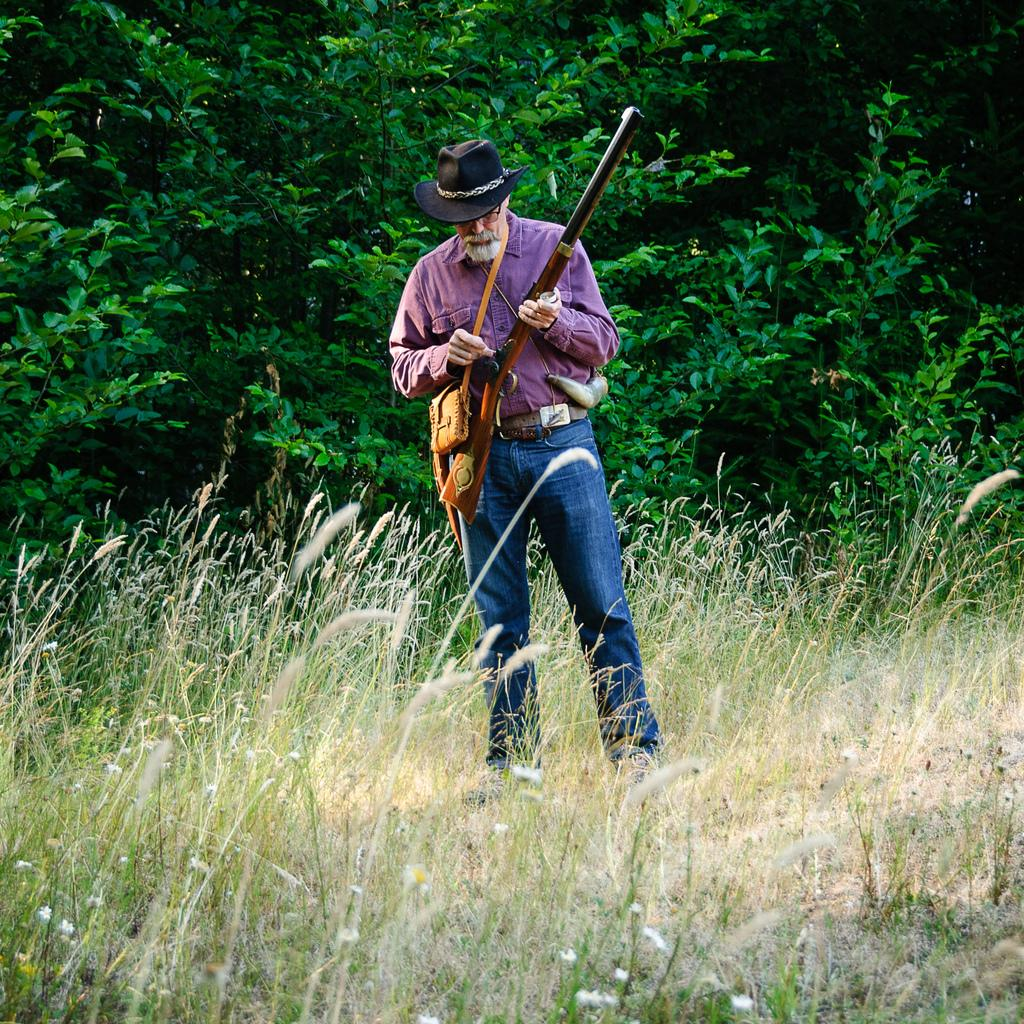What can be seen in the image? There is a person in the image. What is the person wearing? The person is wearing a hat. What is the person holding? The person is holding a gun. Where is the person standing? The person is standing on the floor. What can be seen in the distance in the image? There are trees visible in the background of the image. What type of wave can be seen in the image? There is no wave present in the image; it features a person holding a gun and standing on the floor with trees visible in the background. 